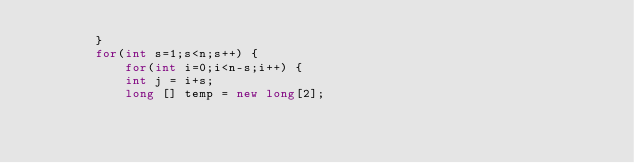Convert code to text. <code><loc_0><loc_0><loc_500><loc_500><_Java_>		}
		for(int s=1;s<n;s++) {
			for(int i=0;i<n-s;i++) {
			int j = i+s;
			long [] temp = new long[2];</code> 